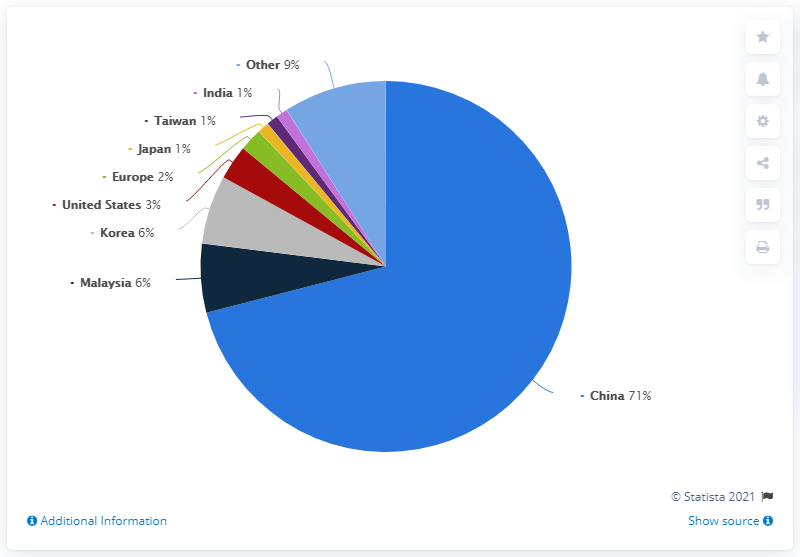Can you explain what this pie chart is showing? This pie chart represents a distribution of data for certain entities, with China accounting for the majority at 71%. Other entities such as India, Taiwan, Japan, Europe, the United States, Korea, and Malaysia are also included, along with a category labeled 'Other'. The exact nature of the distribution is unclear without additional context, such as the dataset's name, the year it was sourced, and specific data parameters.  How could this data be applied in a real-world situation? Data like this could be used for market analysis, resource allocation, or policy-making, depending on its context. For example, if this were data on market shares for a particular industry, businesses could use it to understand their competition. If it represents population distribution, governments might use it to plan services or infrastructure. 